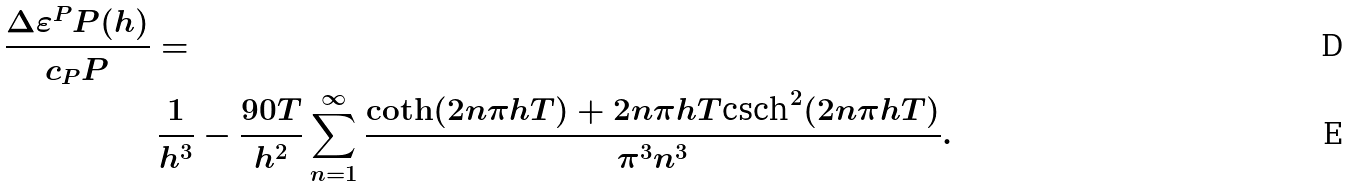<formula> <loc_0><loc_0><loc_500><loc_500>\frac { \Delta \varepsilon ^ { P } P ( h ) } { c _ { P } P } & = \\ & \, \frac { 1 } { h ^ { 3 } } - \frac { 9 0 T } { h ^ { 2 } } \sum _ { n = 1 } ^ { \infty } \frac { \coth ( 2 n \pi h T ) + 2 n \pi h T \text {csch} ^ { 2 } ( 2 n \pi h T ) } { \pi ^ { 3 } n ^ { 3 } } .</formula> 